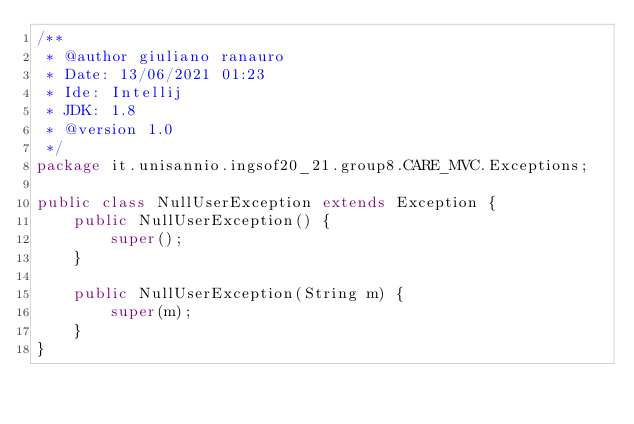Convert code to text. <code><loc_0><loc_0><loc_500><loc_500><_Java_>/**
 * @author giuliano ranauro
 * Date: 13/06/2021 01:23
 * Ide: Intellij
 * JDK: 1.8
 * @version 1.0
 */
package it.unisannio.ingsof20_21.group8.CARE_MVC.Exceptions;

public class NullUserException extends Exception {
    public NullUserException() {
        super();
    }

    public NullUserException(String m) {
        super(m);
    }
}
</code> 